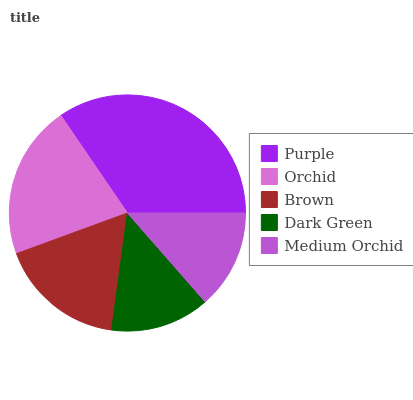Is Medium Orchid the minimum?
Answer yes or no. Yes. Is Purple the maximum?
Answer yes or no. Yes. Is Orchid the minimum?
Answer yes or no. No. Is Orchid the maximum?
Answer yes or no. No. Is Purple greater than Orchid?
Answer yes or no. Yes. Is Orchid less than Purple?
Answer yes or no. Yes. Is Orchid greater than Purple?
Answer yes or no. No. Is Purple less than Orchid?
Answer yes or no. No. Is Brown the high median?
Answer yes or no. Yes. Is Brown the low median?
Answer yes or no. Yes. Is Purple the high median?
Answer yes or no. No. Is Orchid the low median?
Answer yes or no. No. 